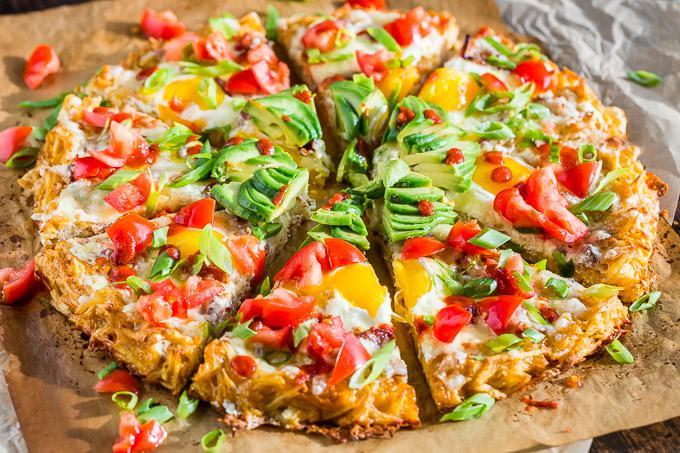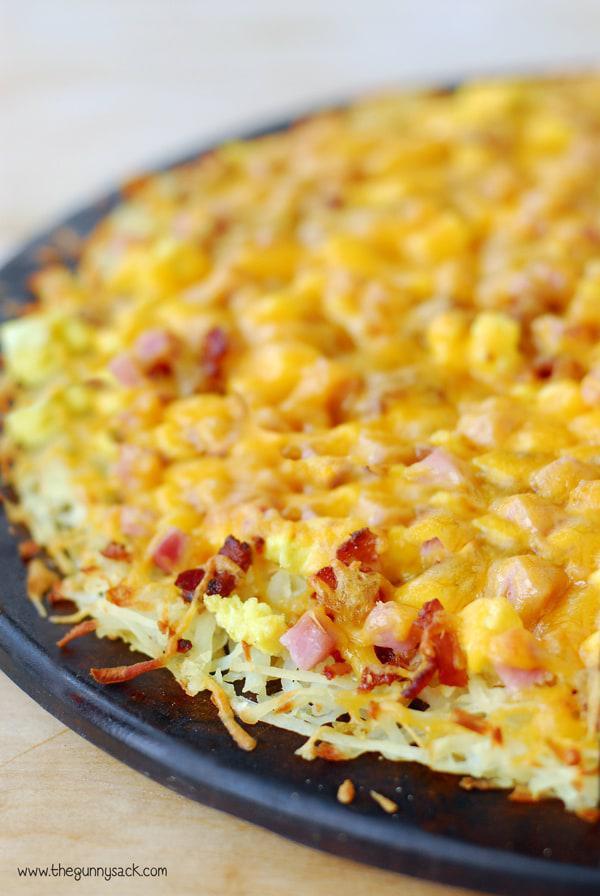The first image is the image on the left, the second image is the image on the right. For the images shown, is this caption "Both pizzas are cut into slices." true? Answer yes or no. No. The first image is the image on the left, the second image is the image on the right. Analyze the images presented: Is the assertion "There are two round pizzas and at least one has avocados in the middle of the pizza." valid? Answer yes or no. Yes. 